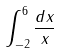Convert formula to latex. <formula><loc_0><loc_0><loc_500><loc_500>\int _ { - 2 } ^ { 6 } \frac { d x } { x }</formula> 